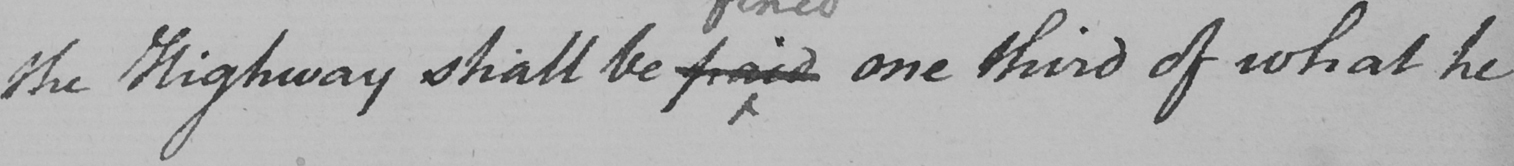What text is written in this handwritten line? the Highway shall be paid one third of what he 